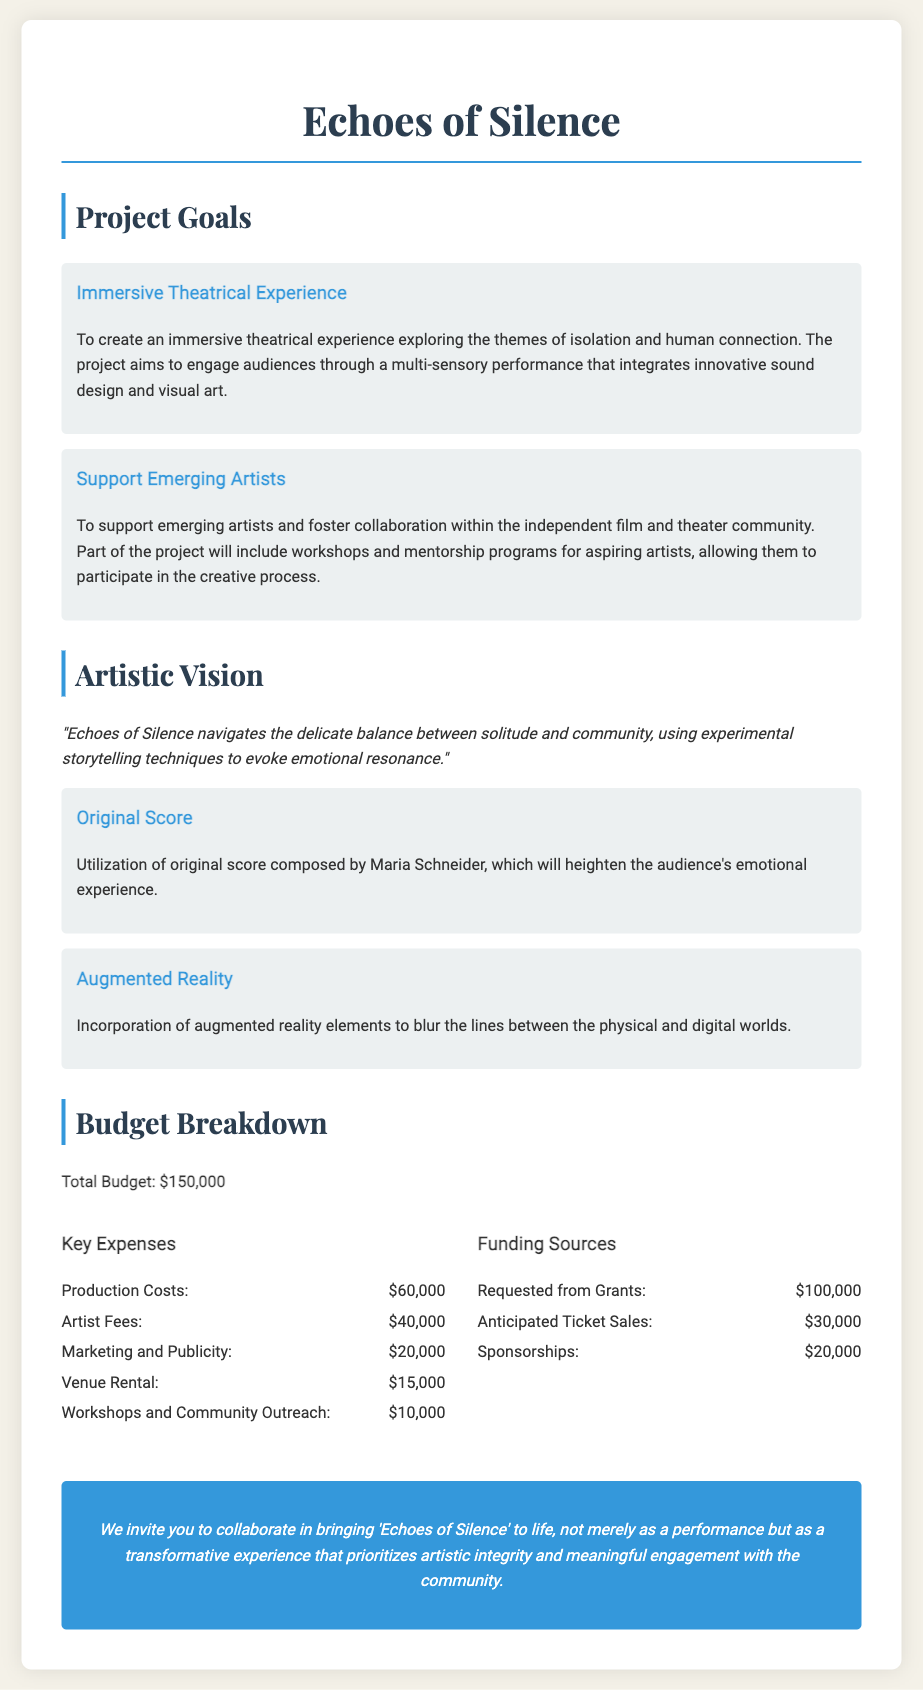What are the project goals? The project goals include creating an immersive theatrical experience and supporting emerging artists, as stated in the document.
Answer: Immersive Theatrical Experience, Support Emerging Artists Who composed the original score? The document specifies that the original score was composed by Maria Schneider.
Answer: Maria Schneider What is the total budget for the project? The total budget for the project is explicitly stated at the beginning of the budget breakdown section.
Answer: $150,000 How much is requested from grants? The document indicates the amount requested from grants under the funding sources section.
Answer: $100,000 What is one unique element of the project? The document lists unique elements, including the original score and augmented reality elements, which enhance the project.
Answer: Original Score What percentage of the budget is allocated for production costs? The production costs are noted to be $60,000 out of a total budget of $150,000, allowing for calculation of the percentage.
Answer: 40% What is the artistic vision of the project? The artistic vision is summarized in a statement that reflects its core themes and techniques as mentioned in the document.
Answer: "Echoes of Silence navigates the delicate balance between solitude and community..." What is the allocation for marketing and publicity? The document lists marketing and publicity as a budget item under key expenses, providing the specific allocation amount.
Answer: $20,000 What is a goal aimed at community engagement? The document states that part of the project includes workshops and mentorship programs, aimed at community engagement.
Answer: Workshops and Community Outreach 